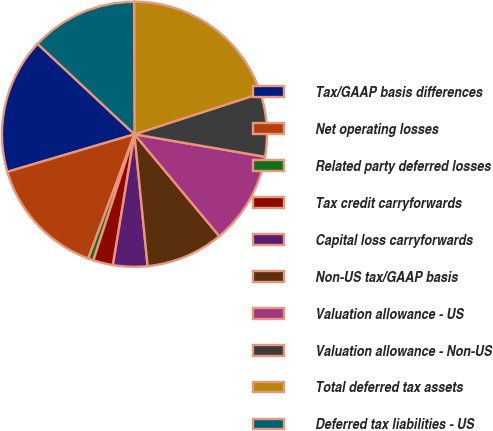<chart> <loc_0><loc_0><loc_500><loc_500><pie_chart><fcel>Tax/GAAP basis differences<fcel>Net operating losses<fcel>Related party deferred losses<fcel>Tax credit carryforwards<fcel>Capital loss carryforwards<fcel>Non-US tax/GAAP basis<fcel>Valuation allowance - US<fcel>Valuation allowance - Non-US<fcel>Total deferred tax assets<fcel>Deferred tax liabilities - US<nl><fcel>16.53%<fcel>14.76%<fcel>0.65%<fcel>2.42%<fcel>4.18%<fcel>9.47%<fcel>11.23%<fcel>7.71%<fcel>20.05%<fcel>13.0%<nl></chart> 